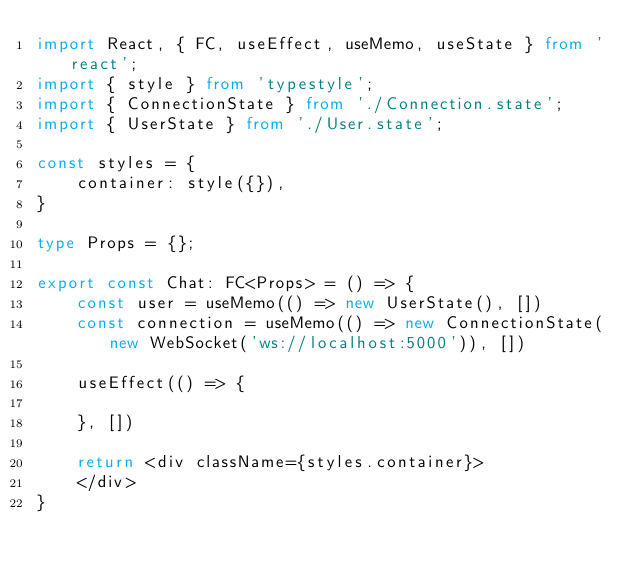Convert code to text. <code><loc_0><loc_0><loc_500><loc_500><_TypeScript_>import React, { FC, useEffect, useMemo, useState } from 'react';
import { style } from 'typestyle';
import { ConnectionState } from './Connection.state';
import { UserState } from './User.state';

const styles = {
	container: style({}),
}

type Props = {};

export const Chat: FC<Props> = () => {
	const user = useMemo(() => new UserState(), [])
	const connection = useMemo(() => new ConnectionState(new WebSocket('ws://localhost:5000')), [])

	useEffect(() => {

	}, [])

	return <div className={styles.container}>
	</div>
}
</code> 